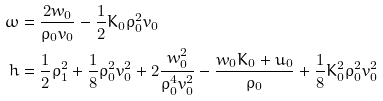Convert formula to latex. <formula><loc_0><loc_0><loc_500><loc_500>\omega & = \frac { 2 w _ { 0 } } { \rho _ { 0 } v _ { 0 } } - \frac { 1 } { 2 } K _ { 0 } \rho _ { 0 } ^ { 2 } v _ { 0 } \\ h & = \frac { 1 } { 2 } \rho _ { 1 } ^ { 2 } + \frac { 1 } { 8 } \rho _ { 0 } ^ { 2 } v _ { 0 } ^ { 2 } + 2 \frac { w _ { 0 } ^ { 2 } } { \rho _ { 0 } ^ { 4 } v _ { 0 } ^ { 2 } } - \frac { w _ { 0 } K _ { 0 } + u _ { 0 } } { \rho _ { 0 } } + \frac { 1 } { 8 } K _ { 0 } ^ { 2 } \rho _ { 0 } ^ { 2 } v _ { 0 } ^ { 2 }</formula> 